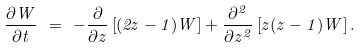Convert formula to latex. <formula><loc_0><loc_0><loc_500><loc_500>\frac { \partial W } { \partial t } \ = \ - \frac { \partial } { \partial z } \left [ ( 2 z - 1 ) W \right ] + \frac { \partial ^ { 2 } } { \partial z ^ { 2 } } \left [ z ( z - 1 ) W \right ] .</formula> 